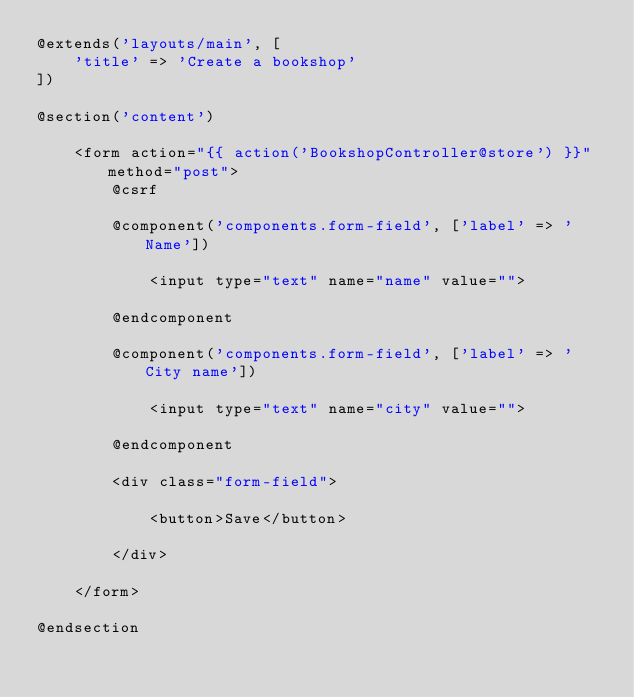Convert code to text. <code><loc_0><loc_0><loc_500><loc_500><_PHP_>@extends('layouts/main', [
    'title' => 'Create a bookshop'
])

@section('content')

    <form action="{{ action('BookshopController@store') }}" method="post">
        @csrf

        @component('components.form-field', ['label' => 'Name'])

            <input type="text" name="name" value="">

        @endcomponent

        @component('components.form-field', ['label' => 'City name'])

            <input type="text" name="city" value="">

        @endcomponent

        <div class="form-field">

            <button>Save</button>

        </div>

    </form>

@endsection</code> 